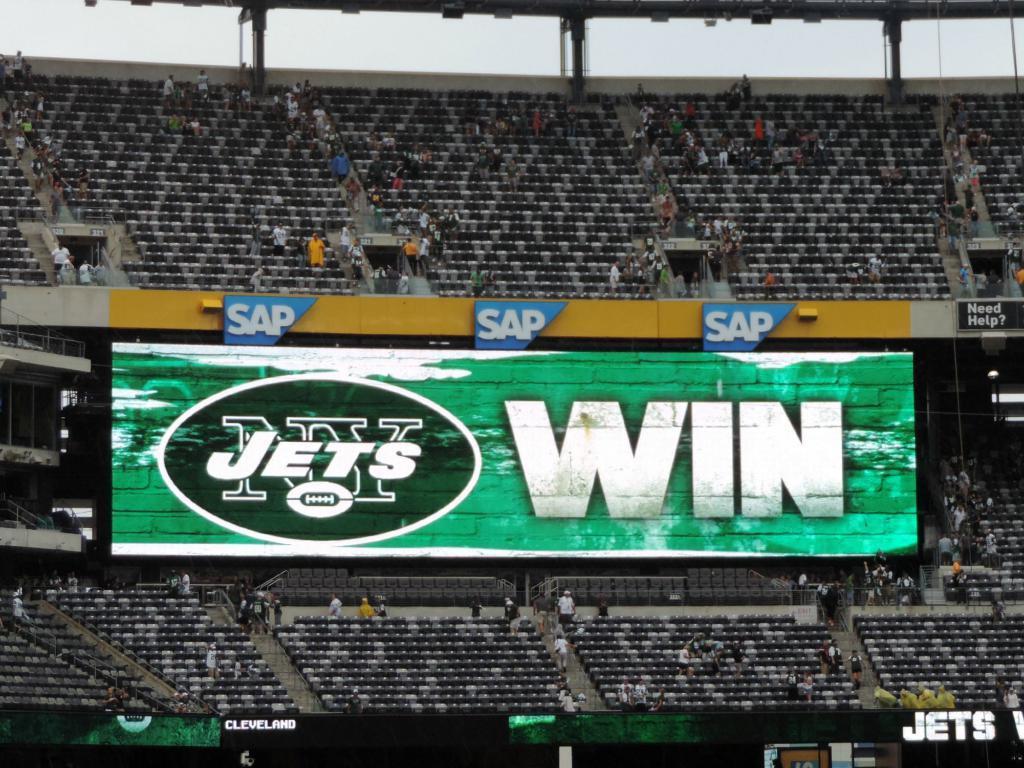Describe this image in one or two sentences. This is a stadium where we can see only chairs, poles, hoardings, steps, screen, few persons are standing and the sky. 